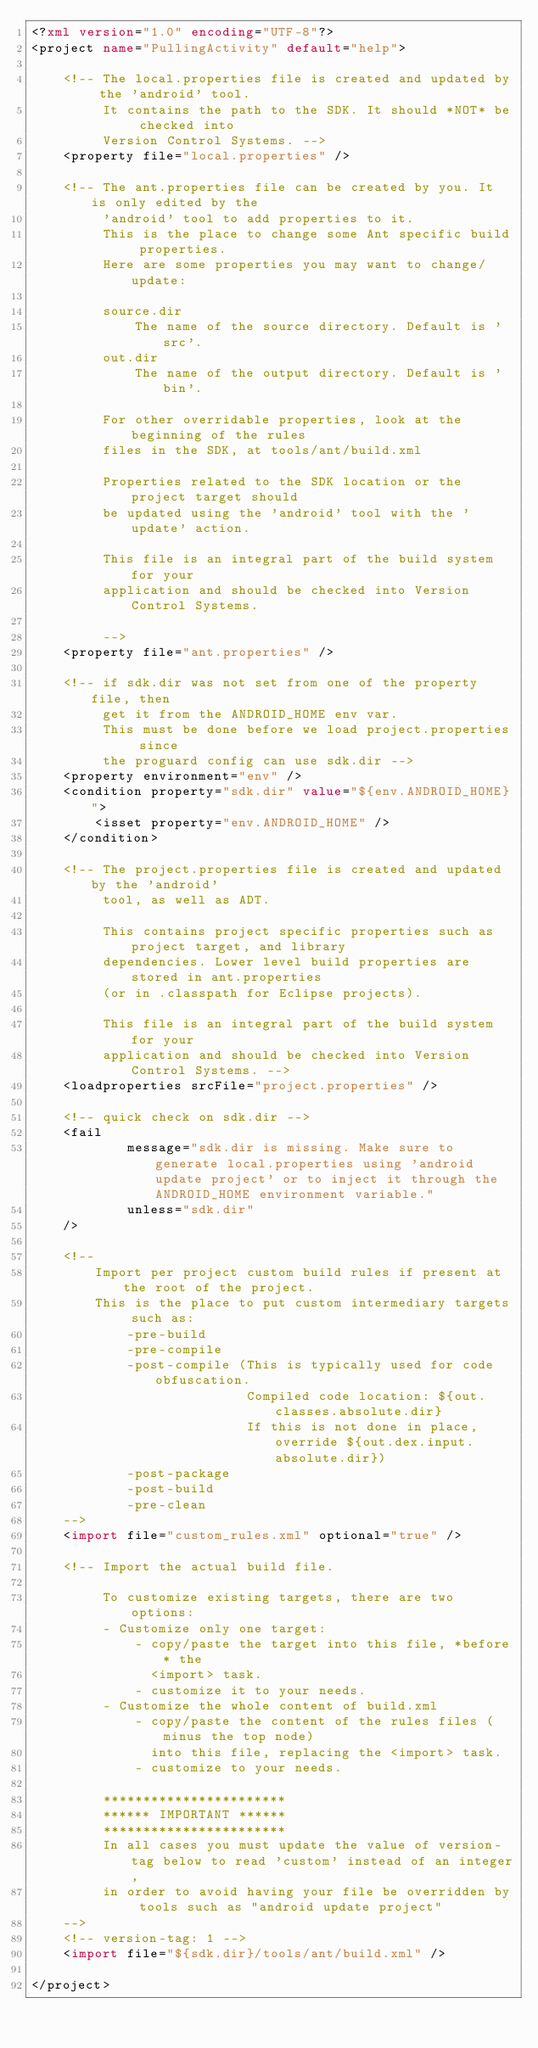<code> <loc_0><loc_0><loc_500><loc_500><_XML_><?xml version="1.0" encoding="UTF-8"?>
<project name="PullingActivity" default="help">

    <!-- The local.properties file is created and updated by the 'android' tool.
         It contains the path to the SDK. It should *NOT* be checked into
         Version Control Systems. -->
    <property file="local.properties" />

    <!-- The ant.properties file can be created by you. It is only edited by the
         'android' tool to add properties to it.
         This is the place to change some Ant specific build properties.
         Here are some properties you may want to change/update:

         source.dir
             The name of the source directory. Default is 'src'.
         out.dir
             The name of the output directory. Default is 'bin'.

         For other overridable properties, look at the beginning of the rules
         files in the SDK, at tools/ant/build.xml

         Properties related to the SDK location or the project target should
         be updated using the 'android' tool with the 'update' action.

         This file is an integral part of the build system for your
         application and should be checked into Version Control Systems.

         -->
    <property file="ant.properties" />

    <!-- if sdk.dir was not set from one of the property file, then
         get it from the ANDROID_HOME env var.
         This must be done before we load project.properties since
         the proguard config can use sdk.dir -->
    <property environment="env" />
    <condition property="sdk.dir" value="${env.ANDROID_HOME}">
        <isset property="env.ANDROID_HOME" />
    </condition>

    <!-- The project.properties file is created and updated by the 'android'
         tool, as well as ADT.

         This contains project specific properties such as project target, and library
         dependencies. Lower level build properties are stored in ant.properties
         (or in .classpath for Eclipse projects).

         This file is an integral part of the build system for your
         application and should be checked into Version Control Systems. -->
    <loadproperties srcFile="project.properties" />

    <!-- quick check on sdk.dir -->
    <fail
            message="sdk.dir is missing. Make sure to generate local.properties using 'android update project' or to inject it through the ANDROID_HOME environment variable."
            unless="sdk.dir"
    />

    <!--
        Import per project custom build rules if present at the root of the project.
        This is the place to put custom intermediary targets such as:
            -pre-build
            -pre-compile
            -post-compile (This is typically used for code obfuscation.
                           Compiled code location: ${out.classes.absolute.dir}
                           If this is not done in place, override ${out.dex.input.absolute.dir})
            -post-package
            -post-build
            -pre-clean
    -->
    <import file="custom_rules.xml" optional="true" />

    <!-- Import the actual build file.

         To customize existing targets, there are two options:
         - Customize only one target:
             - copy/paste the target into this file, *before* the
               <import> task.
             - customize it to your needs.
         - Customize the whole content of build.xml
             - copy/paste the content of the rules files (minus the top node)
               into this file, replacing the <import> task.
             - customize to your needs.

         ***********************
         ****** IMPORTANT ******
         ***********************
         In all cases you must update the value of version-tag below to read 'custom' instead of an integer,
         in order to avoid having your file be overridden by tools such as "android update project"
    -->
    <!-- version-tag: 1 -->
    <import file="${sdk.dir}/tools/ant/build.xml" />

</project>
</code> 